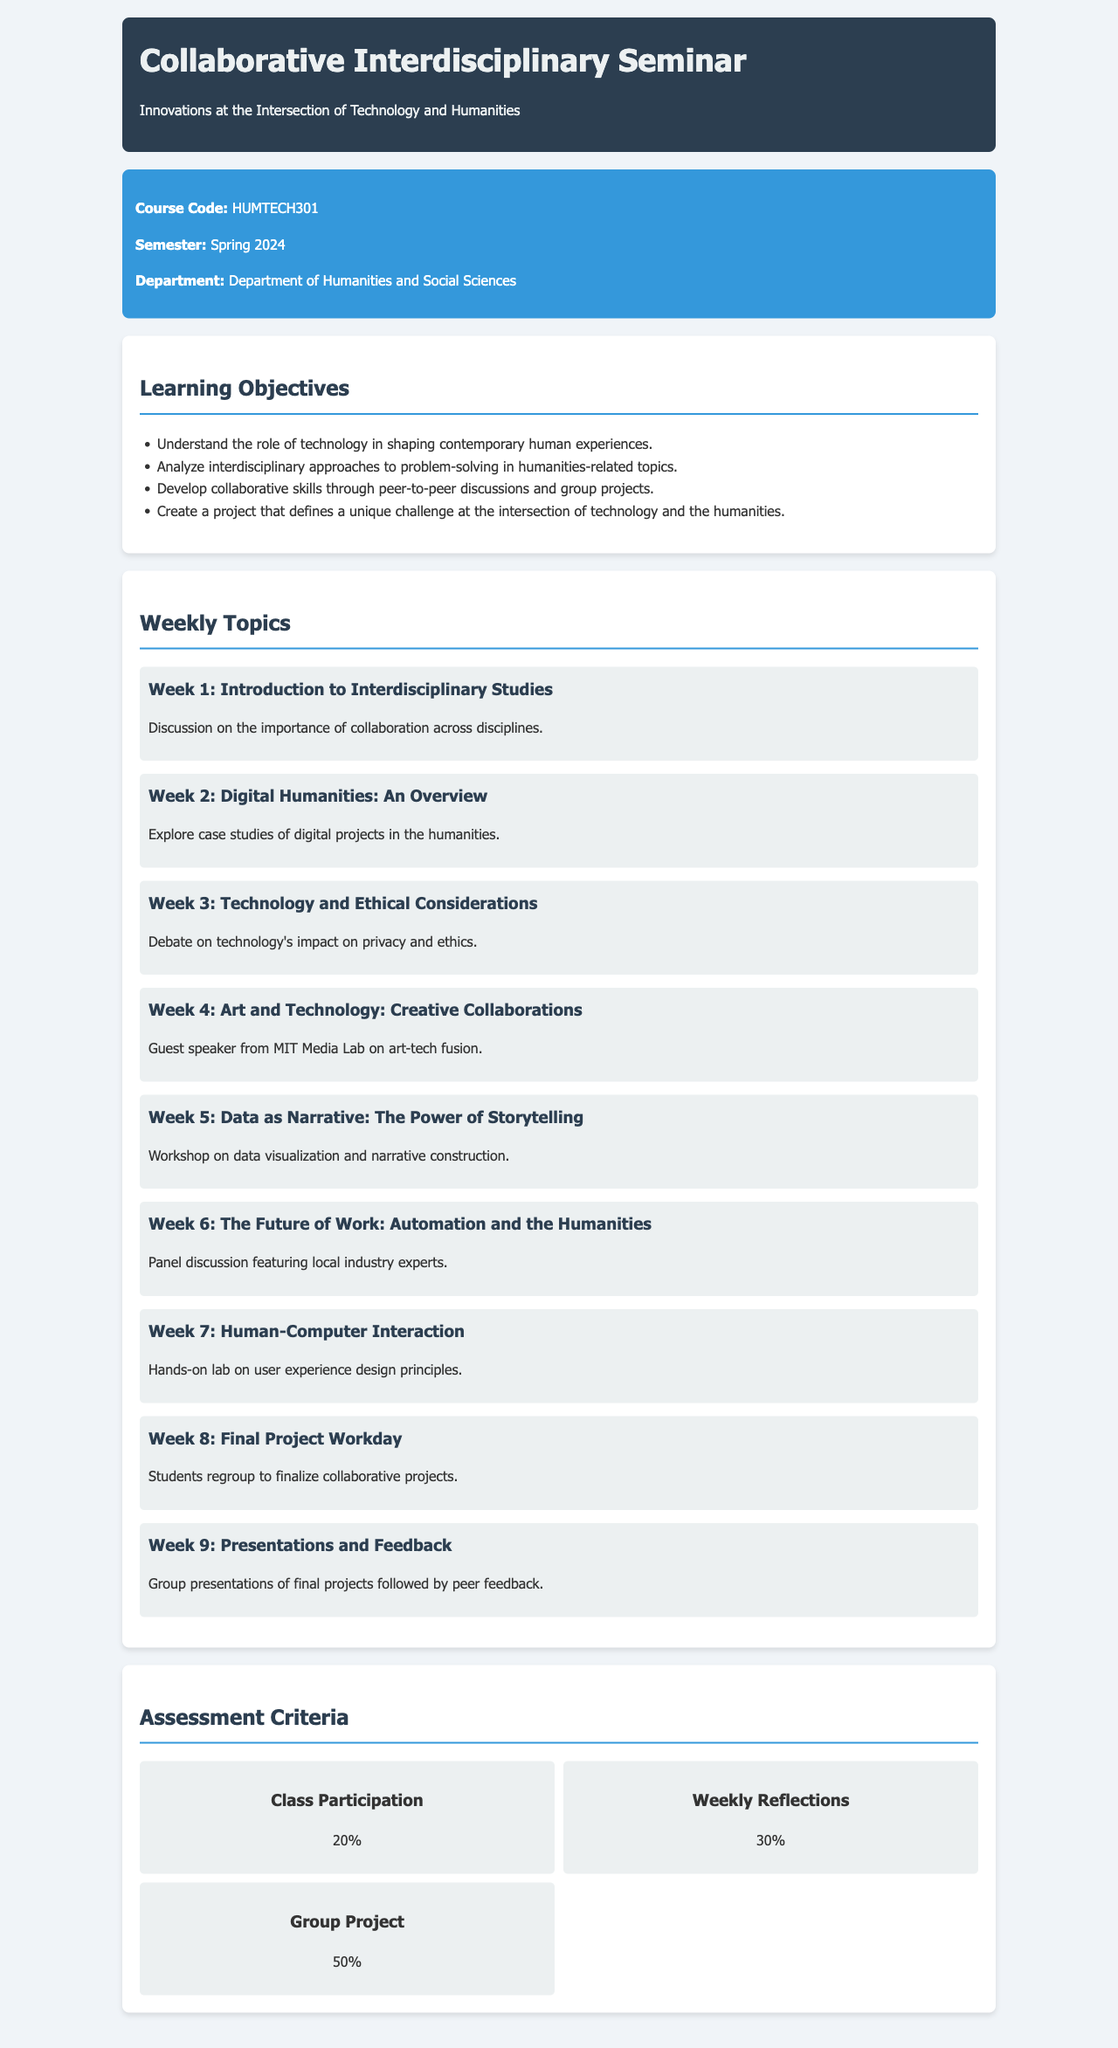What is the course code? The course code is listed in the course information section of the document.
Answer: HUMTECH301 What is the total percentage for the Group Project assessment? The total percentage for the Group Project is found in the assessment criteria section of the document.
Answer: 50% What is the theme of the seminar? The theme of the seminar is mentioned in the header or introduction of the document.
Answer: Innovations at the Intersection of Technology and Humanities How many weekly topics are there in the syllabus? The number of weekly topics can be counted in the weekly topics section of the document.
Answer: 9 Which week discusses Human-Computer Interaction? The specific week can be identified by checking the weekly topics section for the corresponding heading.
Answer: Week 7 What percentage of the assessment is devoted to Class Participation? The percentage for Class Participation can be found in the assessment criteria section.
Answer: 20% What is the title of Week 2's topic? The title of Week 2's topic is explicitly stated in the weekly topics section.
Answer: Digital Humanities: An Overview Who is the guest speaker mentioned in Week 4? The guest speaker is referenced in the description of Week 4 in the weekly topics section.
Answer: Guest speaker from MIT Media Lab What type of project do students create? The type of project students create is described in the learning objectives section of the document.
Answer: A project that defines a unique challenge at the intersection of technology and the humanities 